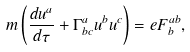Convert formula to latex. <formula><loc_0><loc_0><loc_500><loc_500>m \left ( \frac { d u ^ { a } } { d \tau } + \Gamma ^ { a } _ { b c } u ^ { b } u ^ { c } \right ) = e F ^ { a b } _ { b } ,</formula> 